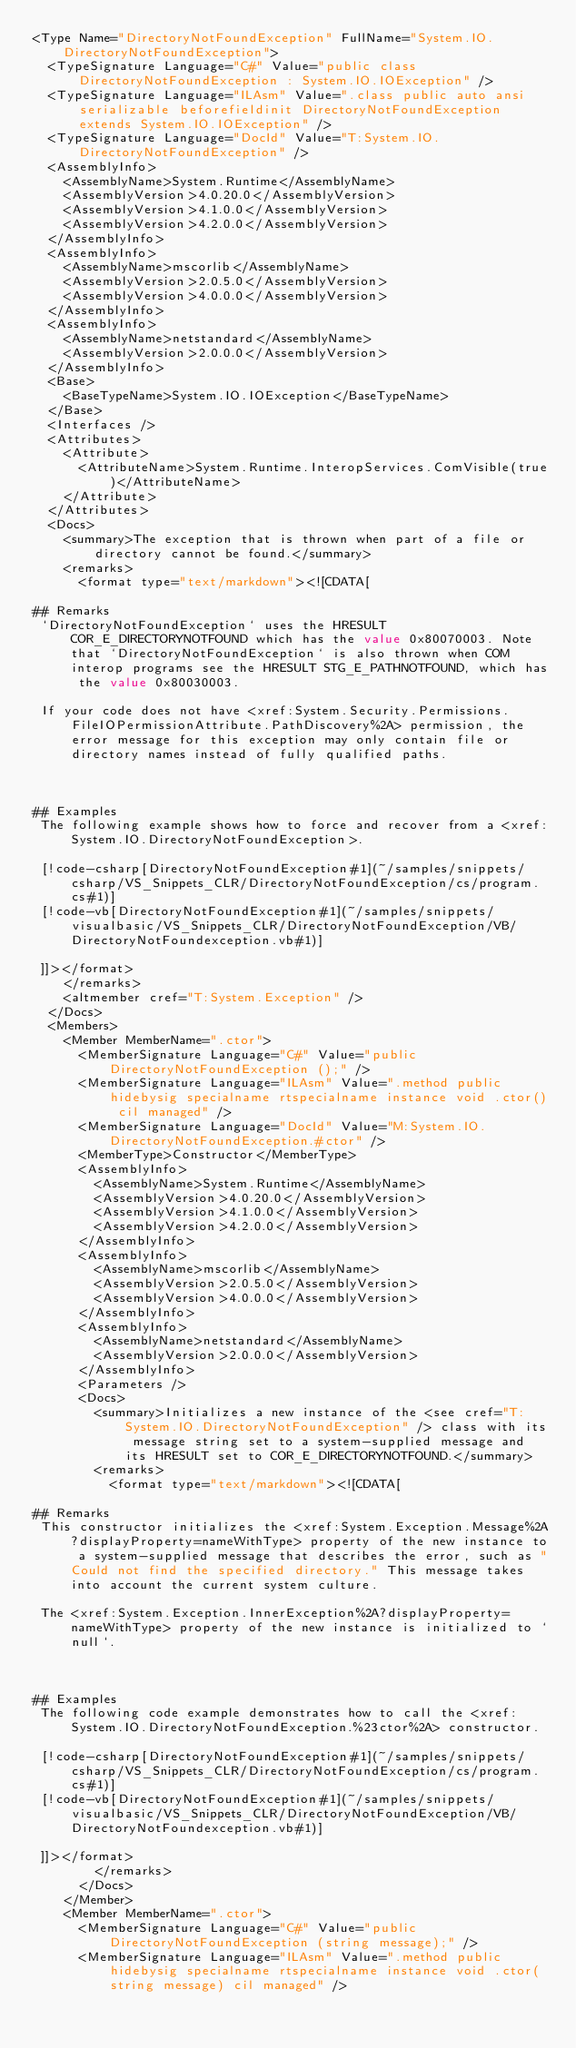Convert code to text. <code><loc_0><loc_0><loc_500><loc_500><_XML_><Type Name="DirectoryNotFoundException" FullName="System.IO.DirectoryNotFoundException">
  <TypeSignature Language="C#" Value="public class DirectoryNotFoundException : System.IO.IOException" />
  <TypeSignature Language="ILAsm" Value=".class public auto ansi serializable beforefieldinit DirectoryNotFoundException extends System.IO.IOException" />
  <TypeSignature Language="DocId" Value="T:System.IO.DirectoryNotFoundException" />
  <AssemblyInfo>
    <AssemblyName>System.Runtime</AssemblyName>
    <AssemblyVersion>4.0.20.0</AssemblyVersion>
    <AssemblyVersion>4.1.0.0</AssemblyVersion>
    <AssemblyVersion>4.2.0.0</AssemblyVersion>
  </AssemblyInfo>
  <AssemblyInfo>
    <AssemblyName>mscorlib</AssemblyName>
    <AssemblyVersion>2.0.5.0</AssemblyVersion>
    <AssemblyVersion>4.0.0.0</AssemblyVersion>
  </AssemblyInfo>
  <AssemblyInfo>
    <AssemblyName>netstandard</AssemblyName>
    <AssemblyVersion>2.0.0.0</AssemblyVersion>
  </AssemblyInfo>
  <Base>
    <BaseTypeName>System.IO.IOException</BaseTypeName>
  </Base>
  <Interfaces />
  <Attributes>
    <Attribute>
      <AttributeName>System.Runtime.InteropServices.ComVisible(true)</AttributeName>
    </Attribute>
  </Attributes>
  <Docs>
    <summary>The exception that is thrown when part of a file or directory cannot be found.</summary>
    <remarks>
      <format type="text/markdown"><![CDATA[  
  
## Remarks  
 `DirectoryNotFoundException` uses the HRESULT COR_E_DIRECTORYNOTFOUND which has the value 0x80070003. Note that `DirectoryNotFoundException` is also thrown when COM interop programs see the HRESULT STG_E_PATHNOTFOUND, which has the value 0x80030003.  
  
 If your code does not have <xref:System.Security.Permissions.FileIOPermissionAttribute.PathDiscovery%2A> permission, the error message for this exception may only contain file or directory names instead of fully qualified paths.  
  
   
  
## Examples  
 The following example shows how to force and recover from a <xref:System.IO.DirectoryNotFoundException>.  
  
 [!code-csharp[DirectoryNotFoundException#1](~/samples/snippets/csharp/VS_Snippets_CLR/DirectoryNotFoundException/cs/program.cs#1)]
 [!code-vb[DirectoryNotFoundException#1](~/samples/snippets/visualbasic/VS_Snippets_CLR/DirectoryNotFoundException/VB/DirectoryNotFoundexception.vb#1)]  
  
 ]]></format>
    </remarks>
    <altmember cref="T:System.Exception" />
  </Docs>
  <Members>
    <Member MemberName=".ctor">
      <MemberSignature Language="C#" Value="public DirectoryNotFoundException ();" />
      <MemberSignature Language="ILAsm" Value=".method public hidebysig specialname rtspecialname instance void .ctor() cil managed" />
      <MemberSignature Language="DocId" Value="M:System.IO.DirectoryNotFoundException.#ctor" />
      <MemberType>Constructor</MemberType>
      <AssemblyInfo>
        <AssemblyName>System.Runtime</AssemblyName>
        <AssemblyVersion>4.0.20.0</AssemblyVersion>
        <AssemblyVersion>4.1.0.0</AssemblyVersion>
        <AssemblyVersion>4.2.0.0</AssemblyVersion>
      </AssemblyInfo>
      <AssemblyInfo>
        <AssemblyName>mscorlib</AssemblyName>
        <AssemblyVersion>2.0.5.0</AssemblyVersion>
        <AssemblyVersion>4.0.0.0</AssemblyVersion>
      </AssemblyInfo>
      <AssemblyInfo>
        <AssemblyName>netstandard</AssemblyName>
        <AssemblyVersion>2.0.0.0</AssemblyVersion>
      </AssemblyInfo>
      <Parameters />
      <Docs>
        <summary>Initializes a new instance of the <see cref="T:System.IO.DirectoryNotFoundException" /> class with its message string set to a system-supplied message and its HRESULT set to COR_E_DIRECTORYNOTFOUND.</summary>
        <remarks>
          <format type="text/markdown"><![CDATA[  
  
## Remarks  
 This constructor initializes the <xref:System.Exception.Message%2A?displayProperty=nameWithType> property of the new instance to a system-supplied message that describes the error, such as "Could not find the specified directory." This message takes into account the current system culture.  
  
 The <xref:System.Exception.InnerException%2A?displayProperty=nameWithType> property of the new instance is initialized to `null`.  
  
   
  
## Examples  
 The following code example demonstrates how to call the <xref:System.IO.DirectoryNotFoundException.%23ctor%2A> constructor.  
  
 [!code-csharp[DirectoryNotFoundException#1](~/samples/snippets/csharp/VS_Snippets_CLR/DirectoryNotFoundException/cs/program.cs#1)]
 [!code-vb[DirectoryNotFoundException#1](~/samples/snippets/visualbasic/VS_Snippets_CLR/DirectoryNotFoundException/VB/DirectoryNotFoundexception.vb#1)]  
  
 ]]></format>
        </remarks>
      </Docs>
    </Member>
    <Member MemberName=".ctor">
      <MemberSignature Language="C#" Value="public DirectoryNotFoundException (string message);" />
      <MemberSignature Language="ILAsm" Value=".method public hidebysig specialname rtspecialname instance void .ctor(string message) cil managed" /></code> 